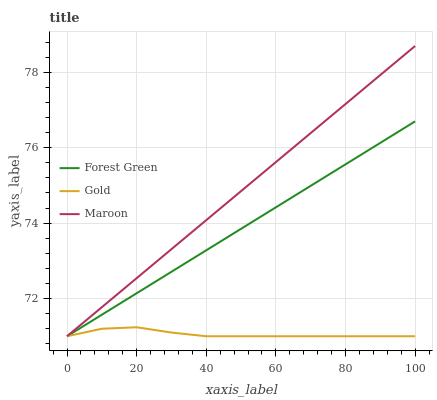Does Gold have the minimum area under the curve?
Answer yes or no. Yes. Does Maroon have the maximum area under the curve?
Answer yes or no. Yes. Does Maroon have the minimum area under the curve?
Answer yes or no. No. Does Gold have the maximum area under the curve?
Answer yes or no. No. Is Forest Green the smoothest?
Answer yes or no. Yes. Is Gold the roughest?
Answer yes or no. Yes. Is Maroon the smoothest?
Answer yes or no. No. Is Maroon the roughest?
Answer yes or no. No. Does Forest Green have the lowest value?
Answer yes or no. Yes. Does Maroon have the highest value?
Answer yes or no. Yes. Does Gold have the highest value?
Answer yes or no. No. Does Gold intersect Maroon?
Answer yes or no. Yes. Is Gold less than Maroon?
Answer yes or no. No. Is Gold greater than Maroon?
Answer yes or no. No. 